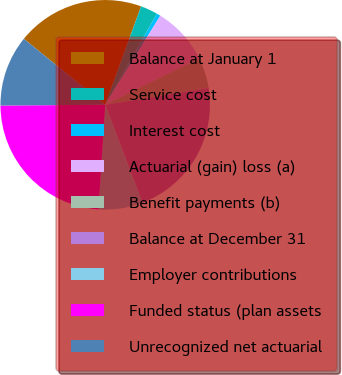<chart> <loc_0><loc_0><loc_500><loc_500><pie_chart><fcel>Balance at January 1<fcel>Service cost<fcel>Interest cost<fcel>Actuarial (gain) loss (a)<fcel>Benefit payments (b)<fcel>Balance at December 31<fcel>Employer contributions<fcel>Funded status (plan assets<fcel>Unrecognized net actuarial<nl><fcel>19.72%<fcel>2.66%<fcel>0.59%<fcel>8.88%<fcel>4.74%<fcel>21.79%<fcel>6.81%<fcel>23.86%<fcel>10.95%<nl></chart> 